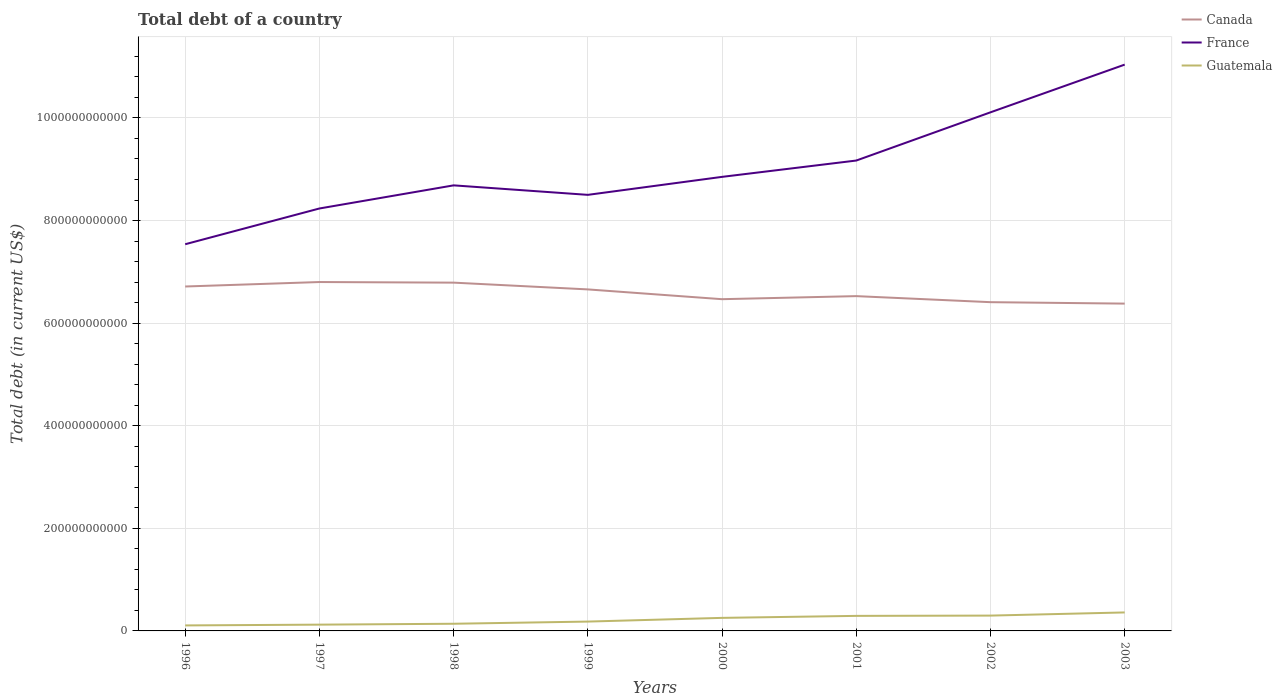How many different coloured lines are there?
Offer a very short reply. 3. Does the line corresponding to Canada intersect with the line corresponding to Guatemala?
Provide a short and direct response. No. Is the number of lines equal to the number of legend labels?
Provide a short and direct response. Yes. Across all years, what is the maximum debt in France?
Your answer should be compact. 7.54e+11. What is the total debt in France in the graph?
Offer a very short reply. -2.35e+11. What is the difference between the highest and the second highest debt in Guatemala?
Offer a terse response. 2.53e+1. What is the difference between the highest and the lowest debt in France?
Give a very brief answer. 3. How many lines are there?
Offer a very short reply. 3. What is the difference between two consecutive major ticks on the Y-axis?
Keep it short and to the point. 2.00e+11. Does the graph contain any zero values?
Make the answer very short. No. Does the graph contain grids?
Ensure brevity in your answer.  Yes. How many legend labels are there?
Your answer should be very brief. 3. What is the title of the graph?
Offer a terse response. Total debt of a country. Does "World" appear as one of the legend labels in the graph?
Your answer should be compact. No. What is the label or title of the Y-axis?
Your answer should be compact. Total debt (in current US$). What is the Total debt (in current US$) of Canada in 1996?
Your answer should be compact. 6.71e+11. What is the Total debt (in current US$) in France in 1996?
Make the answer very short. 7.54e+11. What is the Total debt (in current US$) in Guatemala in 1996?
Ensure brevity in your answer.  1.07e+1. What is the Total debt (in current US$) of Canada in 1997?
Ensure brevity in your answer.  6.80e+11. What is the Total debt (in current US$) of France in 1997?
Offer a very short reply. 8.24e+11. What is the Total debt (in current US$) of Guatemala in 1997?
Provide a succinct answer. 1.22e+1. What is the Total debt (in current US$) of Canada in 1998?
Offer a very short reply. 6.79e+11. What is the Total debt (in current US$) in France in 1998?
Ensure brevity in your answer.  8.69e+11. What is the Total debt (in current US$) of Guatemala in 1998?
Offer a very short reply. 1.40e+1. What is the Total debt (in current US$) in Canada in 1999?
Your answer should be very brief. 6.66e+11. What is the Total debt (in current US$) of France in 1999?
Keep it short and to the point. 8.50e+11. What is the Total debt (in current US$) in Guatemala in 1999?
Offer a very short reply. 1.82e+1. What is the Total debt (in current US$) of Canada in 2000?
Provide a succinct answer. 6.47e+11. What is the Total debt (in current US$) of France in 2000?
Provide a succinct answer. 8.85e+11. What is the Total debt (in current US$) of Guatemala in 2000?
Offer a terse response. 2.54e+1. What is the Total debt (in current US$) in Canada in 2001?
Keep it short and to the point. 6.53e+11. What is the Total debt (in current US$) of France in 2001?
Your answer should be very brief. 9.17e+11. What is the Total debt (in current US$) of Guatemala in 2001?
Provide a succinct answer. 2.93e+1. What is the Total debt (in current US$) in Canada in 2002?
Offer a terse response. 6.41e+11. What is the Total debt (in current US$) of France in 2002?
Ensure brevity in your answer.  1.01e+12. What is the Total debt (in current US$) in Guatemala in 2002?
Your answer should be compact. 2.99e+1. What is the Total debt (in current US$) in Canada in 2003?
Provide a short and direct response. 6.38e+11. What is the Total debt (in current US$) of France in 2003?
Your answer should be compact. 1.10e+12. What is the Total debt (in current US$) in Guatemala in 2003?
Your answer should be compact. 3.60e+1. Across all years, what is the maximum Total debt (in current US$) of Canada?
Offer a terse response. 6.80e+11. Across all years, what is the maximum Total debt (in current US$) in France?
Give a very brief answer. 1.10e+12. Across all years, what is the maximum Total debt (in current US$) in Guatemala?
Make the answer very short. 3.60e+1. Across all years, what is the minimum Total debt (in current US$) of Canada?
Your answer should be compact. 6.38e+11. Across all years, what is the minimum Total debt (in current US$) in France?
Provide a short and direct response. 7.54e+11. Across all years, what is the minimum Total debt (in current US$) of Guatemala?
Make the answer very short. 1.07e+1. What is the total Total debt (in current US$) in Canada in the graph?
Provide a succinct answer. 5.27e+12. What is the total Total debt (in current US$) in France in the graph?
Your answer should be very brief. 7.21e+12. What is the total Total debt (in current US$) of Guatemala in the graph?
Provide a short and direct response. 1.76e+11. What is the difference between the Total debt (in current US$) of Canada in 1996 and that in 1997?
Your response must be concise. -8.71e+09. What is the difference between the Total debt (in current US$) of France in 1996 and that in 1997?
Your answer should be compact. -6.97e+1. What is the difference between the Total debt (in current US$) in Guatemala in 1996 and that in 1997?
Your answer should be very brief. -1.50e+09. What is the difference between the Total debt (in current US$) in Canada in 1996 and that in 1998?
Your answer should be very brief. -7.54e+09. What is the difference between the Total debt (in current US$) of France in 1996 and that in 1998?
Your answer should be very brief. -1.15e+11. What is the difference between the Total debt (in current US$) of Guatemala in 1996 and that in 1998?
Ensure brevity in your answer.  -3.26e+09. What is the difference between the Total debt (in current US$) of Canada in 1996 and that in 1999?
Offer a terse response. 5.66e+09. What is the difference between the Total debt (in current US$) in France in 1996 and that in 1999?
Offer a very short reply. -9.63e+1. What is the difference between the Total debt (in current US$) in Guatemala in 1996 and that in 1999?
Provide a short and direct response. -7.49e+09. What is the difference between the Total debt (in current US$) of Canada in 1996 and that in 2000?
Your answer should be very brief. 2.47e+1. What is the difference between the Total debt (in current US$) of France in 1996 and that in 2000?
Ensure brevity in your answer.  -1.31e+11. What is the difference between the Total debt (in current US$) in Guatemala in 1996 and that in 2000?
Ensure brevity in your answer.  -1.47e+1. What is the difference between the Total debt (in current US$) of Canada in 1996 and that in 2001?
Make the answer very short. 1.88e+1. What is the difference between the Total debt (in current US$) of France in 1996 and that in 2001?
Make the answer very short. -1.63e+11. What is the difference between the Total debt (in current US$) of Guatemala in 1996 and that in 2001?
Your answer should be compact. -1.86e+1. What is the difference between the Total debt (in current US$) of Canada in 1996 and that in 2002?
Ensure brevity in your answer.  3.06e+1. What is the difference between the Total debt (in current US$) of France in 1996 and that in 2002?
Provide a succinct answer. -2.57e+11. What is the difference between the Total debt (in current US$) of Guatemala in 1996 and that in 2002?
Your response must be concise. -1.92e+1. What is the difference between the Total debt (in current US$) of Canada in 1996 and that in 2003?
Offer a very short reply. 3.33e+1. What is the difference between the Total debt (in current US$) of France in 1996 and that in 2003?
Your answer should be very brief. -3.50e+11. What is the difference between the Total debt (in current US$) of Guatemala in 1996 and that in 2003?
Give a very brief answer. -2.53e+1. What is the difference between the Total debt (in current US$) of Canada in 1997 and that in 1998?
Your response must be concise. 1.16e+09. What is the difference between the Total debt (in current US$) in France in 1997 and that in 1998?
Offer a terse response. -4.51e+1. What is the difference between the Total debt (in current US$) in Guatemala in 1997 and that in 1998?
Ensure brevity in your answer.  -1.75e+09. What is the difference between the Total debt (in current US$) of Canada in 1997 and that in 1999?
Ensure brevity in your answer.  1.44e+1. What is the difference between the Total debt (in current US$) of France in 1997 and that in 1999?
Offer a terse response. -2.66e+1. What is the difference between the Total debt (in current US$) of Guatemala in 1997 and that in 1999?
Give a very brief answer. -5.98e+09. What is the difference between the Total debt (in current US$) of Canada in 1997 and that in 2000?
Offer a terse response. 3.34e+1. What is the difference between the Total debt (in current US$) of France in 1997 and that in 2000?
Make the answer very short. -6.16e+1. What is the difference between the Total debt (in current US$) of Guatemala in 1997 and that in 2000?
Keep it short and to the point. -1.32e+1. What is the difference between the Total debt (in current US$) in Canada in 1997 and that in 2001?
Provide a succinct answer. 2.75e+1. What is the difference between the Total debt (in current US$) of France in 1997 and that in 2001?
Provide a succinct answer. -9.35e+1. What is the difference between the Total debt (in current US$) in Guatemala in 1997 and that in 2001?
Offer a terse response. -1.71e+1. What is the difference between the Total debt (in current US$) of Canada in 1997 and that in 2002?
Your response must be concise. 3.93e+1. What is the difference between the Total debt (in current US$) of France in 1997 and that in 2002?
Offer a very short reply. -1.87e+11. What is the difference between the Total debt (in current US$) in Guatemala in 1997 and that in 2002?
Ensure brevity in your answer.  -1.77e+1. What is the difference between the Total debt (in current US$) of Canada in 1997 and that in 2003?
Your answer should be very brief. 4.20e+1. What is the difference between the Total debt (in current US$) of France in 1997 and that in 2003?
Provide a succinct answer. -2.80e+11. What is the difference between the Total debt (in current US$) of Guatemala in 1997 and that in 2003?
Provide a succinct answer. -2.38e+1. What is the difference between the Total debt (in current US$) in Canada in 1998 and that in 1999?
Offer a very short reply. 1.32e+1. What is the difference between the Total debt (in current US$) in France in 1998 and that in 1999?
Keep it short and to the point. 1.85e+1. What is the difference between the Total debt (in current US$) in Guatemala in 1998 and that in 1999?
Provide a short and direct response. -4.23e+09. What is the difference between the Total debt (in current US$) in Canada in 1998 and that in 2000?
Provide a short and direct response. 3.23e+1. What is the difference between the Total debt (in current US$) of France in 1998 and that in 2000?
Offer a very short reply. -1.66e+1. What is the difference between the Total debt (in current US$) of Guatemala in 1998 and that in 2000?
Your answer should be very brief. -1.14e+1. What is the difference between the Total debt (in current US$) in Canada in 1998 and that in 2001?
Ensure brevity in your answer.  2.63e+1. What is the difference between the Total debt (in current US$) in France in 1998 and that in 2001?
Ensure brevity in your answer.  -4.84e+1. What is the difference between the Total debt (in current US$) of Guatemala in 1998 and that in 2001?
Provide a succinct answer. -1.53e+1. What is the difference between the Total debt (in current US$) of Canada in 1998 and that in 2002?
Offer a terse response. 3.81e+1. What is the difference between the Total debt (in current US$) in France in 1998 and that in 2002?
Keep it short and to the point. -1.42e+11. What is the difference between the Total debt (in current US$) of Guatemala in 1998 and that in 2002?
Keep it short and to the point. -1.59e+1. What is the difference between the Total debt (in current US$) of Canada in 1998 and that in 2003?
Ensure brevity in your answer.  4.09e+1. What is the difference between the Total debt (in current US$) in France in 1998 and that in 2003?
Offer a terse response. -2.35e+11. What is the difference between the Total debt (in current US$) in Guatemala in 1998 and that in 2003?
Your response must be concise. -2.21e+1. What is the difference between the Total debt (in current US$) of Canada in 1999 and that in 2000?
Provide a succinct answer. 1.91e+1. What is the difference between the Total debt (in current US$) of France in 1999 and that in 2000?
Your response must be concise. -3.51e+1. What is the difference between the Total debt (in current US$) of Guatemala in 1999 and that in 2000?
Ensure brevity in your answer.  -7.21e+09. What is the difference between the Total debt (in current US$) in Canada in 1999 and that in 2001?
Your response must be concise. 1.31e+1. What is the difference between the Total debt (in current US$) in France in 1999 and that in 2001?
Your response must be concise. -6.69e+1. What is the difference between the Total debt (in current US$) in Guatemala in 1999 and that in 2001?
Ensure brevity in your answer.  -1.11e+1. What is the difference between the Total debt (in current US$) of Canada in 1999 and that in 2002?
Your answer should be very brief. 2.49e+1. What is the difference between the Total debt (in current US$) in France in 1999 and that in 2002?
Make the answer very short. -1.61e+11. What is the difference between the Total debt (in current US$) of Guatemala in 1999 and that in 2002?
Offer a terse response. -1.17e+1. What is the difference between the Total debt (in current US$) of Canada in 1999 and that in 2003?
Your answer should be compact. 2.77e+1. What is the difference between the Total debt (in current US$) of France in 1999 and that in 2003?
Ensure brevity in your answer.  -2.54e+11. What is the difference between the Total debt (in current US$) of Guatemala in 1999 and that in 2003?
Your answer should be very brief. -1.78e+1. What is the difference between the Total debt (in current US$) in Canada in 2000 and that in 2001?
Your answer should be compact. -5.98e+09. What is the difference between the Total debt (in current US$) in France in 2000 and that in 2001?
Offer a very short reply. -3.18e+1. What is the difference between the Total debt (in current US$) of Guatemala in 2000 and that in 2001?
Offer a terse response. -3.88e+09. What is the difference between the Total debt (in current US$) in Canada in 2000 and that in 2002?
Make the answer very short. 5.82e+09. What is the difference between the Total debt (in current US$) in France in 2000 and that in 2002?
Provide a short and direct response. -1.26e+11. What is the difference between the Total debt (in current US$) in Guatemala in 2000 and that in 2002?
Offer a very short reply. -4.46e+09. What is the difference between the Total debt (in current US$) of Canada in 2000 and that in 2003?
Ensure brevity in your answer.  8.59e+09. What is the difference between the Total debt (in current US$) of France in 2000 and that in 2003?
Keep it short and to the point. -2.19e+11. What is the difference between the Total debt (in current US$) of Guatemala in 2000 and that in 2003?
Give a very brief answer. -1.06e+1. What is the difference between the Total debt (in current US$) in Canada in 2001 and that in 2002?
Provide a short and direct response. 1.18e+1. What is the difference between the Total debt (in current US$) in France in 2001 and that in 2002?
Your response must be concise. -9.40e+1. What is the difference between the Total debt (in current US$) of Guatemala in 2001 and that in 2002?
Make the answer very short. -5.74e+08. What is the difference between the Total debt (in current US$) in Canada in 2001 and that in 2003?
Offer a very short reply. 1.46e+1. What is the difference between the Total debt (in current US$) of France in 2001 and that in 2003?
Give a very brief answer. -1.87e+11. What is the difference between the Total debt (in current US$) of Guatemala in 2001 and that in 2003?
Keep it short and to the point. -6.73e+09. What is the difference between the Total debt (in current US$) in Canada in 2002 and that in 2003?
Your answer should be compact. 2.78e+09. What is the difference between the Total debt (in current US$) in France in 2002 and that in 2003?
Your answer should be compact. -9.30e+1. What is the difference between the Total debt (in current US$) in Guatemala in 2002 and that in 2003?
Ensure brevity in your answer.  -6.16e+09. What is the difference between the Total debt (in current US$) in Canada in 1996 and the Total debt (in current US$) in France in 1997?
Give a very brief answer. -1.52e+11. What is the difference between the Total debt (in current US$) of Canada in 1996 and the Total debt (in current US$) of Guatemala in 1997?
Offer a terse response. 6.59e+11. What is the difference between the Total debt (in current US$) in France in 1996 and the Total debt (in current US$) in Guatemala in 1997?
Keep it short and to the point. 7.42e+11. What is the difference between the Total debt (in current US$) in Canada in 1996 and the Total debt (in current US$) in France in 1998?
Give a very brief answer. -1.97e+11. What is the difference between the Total debt (in current US$) in Canada in 1996 and the Total debt (in current US$) in Guatemala in 1998?
Offer a terse response. 6.57e+11. What is the difference between the Total debt (in current US$) of France in 1996 and the Total debt (in current US$) of Guatemala in 1998?
Provide a succinct answer. 7.40e+11. What is the difference between the Total debt (in current US$) in Canada in 1996 and the Total debt (in current US$) in France in 1999?
Your response must be concise. -1.79e+11. What is the difference between the Total debt (in current US$) in Canada in 1996 and the Total debt (in current US$) in Guatemala in 1999?
Offer a very short reply. 6.53e+11. What is the difference between the Total debt (in current US$) of France in 1996 and the Total debt (in current US$) of Guatemala in 1999?
Provide a short and direct response. 7.36e+11. What is the difference between the Total debt (in current US$) of Canada in 1996 and the Total debt (in current US$) of France in 2000?
Offer a very short reply. -2.14e+11. What is the difference between the Total debt (in current US$) of Canada in 1996 and the Total debt (in current US$) of Guatemala in 2000?
Your response must be concise. 6.46e+11. What is the difference between the Total debt (in current US$) in France in 1996 and the Total debt (in current US$) in Guatemala in 2000?
Make the answer very short. 7.28e+11. What is the difference between the Total debt (in current US$) in Canada in 1996 and the Total debt (in current US$) in France in 2001?
Give a very brief answer. -2.46e+11. What is the difference between the Total debt (in current US$) of Canada in 1996 and the Total debt (in current US$) of Guatemala in 2001?
Offer a terse response. 6.42e+11. What is the difference between the Total debt (in current US$) in France in 1996 and the Total debt (in current US$) in Guatemala in 2001?
Offer a very short reply. 7.25e+11. What is the difference between the Total debt (in current US$) of Canada in 1996 and the Total debt (in current US$) of France in 2002?
Provide a succinct answer. -3.40e+11. What is the difference between the Total debt (in current US$) in Canada in 1996 and the Total debt (in current US$) in Guatemala in 2002?
Keep it short and to the point. 6.42e+11. What is the difference between the Total debt (in current US$) of France in 1996 and the Total debt (in current US$) of Guatemala in 2002?
Your response must be concise. 7.24e+11. What is the difference between the Total debt (in current US$) of Canada in 1996 and the Total debt (in current US$) of France in 2003?
Provide a succinct answer. -4.33e+11. What is the difference between the Total debt (in current US$) in Canada in 1996 and the Total debt (in current US$) in Guatemala in 2003?
Offer a very short reply. 6.35e+11. What is the difference between the Total debt (in current US$) of France in 1996 and the Total debt (in current US$) of Guatemala in 2003?
Give a very brief answer. 7.18e+11. What is the difference between the Total debt (in current US$) in Canada in 1997 and the Total debt (in current US$) in France in 1998?
Your answer should be very brief. -1.88e+11. What is the difference between the Total debt (in current US$) of Canada in 1997 and the Total debt (in current US$) of Guatemala in 1998?
Offer a very short reply. 6.66e+11. What is the difference between the Total debt (in current US$) of France in 1997 and the Total debt (in current US$) of Guatemala in 1998?
Offer a very short reply. 8.10e+11. What is the difference between the Total debt (in current US$) of Canada in 1997 and the Total debt (in current US$) of France in 1999?
Ensure brevity in your answer.  -1.70e+11. What is the difference between the Total debt (in current US$) of Canada in 1997 and the Total debt (in current US$) of Guatemala in 1999?
Offer a terse response. 6.62e+11. What is the difference between the Total debt (in current US$) in France in 1997 and the Total debt (in current US$) in Guatemala in 1999?
Provide a succinct answer. 8.05e+11. What is the difference between the Total debt (in current US$) of Canada in 1997 and the Total debt (in current US$) of France in 2000?
Offer a terse response. -2.05e+11. What is the difference between the Total debt (in current US$) of Canada in 1997 and the Total debt (in current US$) of Guatemala in 2000?
Offer a terse response. 6.55e+11. What is the difference between the Total debt (in current US$) of France in 1997 and the Total debt (in current US$) of Guatemala in 2000?
Your answer should be very brief. 7.98e+11. What is the difference between the Total debt (in current US$) in Canada in 1997 and the Total debt (in current US$) in France in 2001?
Give a very brief answer. -2.37e+11. What is the difference between the Total debt (in current US$) in Canada in 1997 and the Total debt (in current US$) in Guatemala in 2001?
Provide a short and direct response. 6.51e+11. What is the difference between the Total debt (in current US$) in France in 1997 and the Total debt (in current US$) in Guatemala in 2001?
Make the answer very short. 7.94e+11. What is the difference between the Total debt (in current US$) of Canada in 1997 and the Total debt (in current US$) of France in 2002?
Your answer should be very brief. -3.31e+11. What is the difference between the Total debt (in current US$) of Canada in 1997 and the Total debt (in current US$) of Guatemala in 2002?
Give a very brief answer. 6.50e+11. What is the difference between the Total debt (in current US$) in France in 1997 and the Total debt (in current US$) in Guatemala in 2002?
Ensure brevity in your answer.  7.94e+11. What is the difference between the Total debt (in current US$) of Canada in 1997 and the Total debt (in current US$) of France in 2003?
Your response must be concise. -4.24e+11. What is the difference between the Total debt (in current US$) of Canada in 1997 and the Total debt (in current US$) of Guatemala in 2003?
Ensure brevity in your answer.  6.44e+11. What is the difference between the Total debt (in current US$) in France in 1997 and the Total debt (in current US$) in Guatemala in 2003?
Your response must be concise. 7.87e+11. What is the difference between the Total debt (in current US$) in Canada in 1998 and the Total debt (in current US$) in France in 1999?
Your answer should be compact. -1.71e+11. What is the difference between the Total debt (in current US$) of Canada in 1998 and the Total debt (in current US$) of Guatemala in 1999?
Your answer should be compact. 6.61e+11. What is the difference between the Total debt (in current US$) in France in 1998 and the Total debt (in current US$) in Guatemala in 1999?
Provide a succinct answer. 8.50e+11. What is the difference between the Total debt (in current US$) of Canada in 1998 and the Total debt (in current US$) of France in 2000?
Your answer should be very brief. -2.06e+11. What is the difference between the Total debt (in current US$) in Canada in 1998 and the Total debt (in current US$) in Guatemala in 2000?
Your answer should be compact. 6.54e+11. What is the difference between the Total debt (in current US$) of France in 1998 and the Total debt (in current US$) of Guatemala in 2000?
Offer a terse response. 8.43e+11. What is the difference between the Total debt (in current US$) in Canada in 1998 and the Total debt (in current US$) in France in 2001?
Keep it short and to the point. -2.38e+11. What is the difference between the Total debt (in current US$) of Canada in 1998 and the Total debt (in current US$) of Guatemala in 2001?
Your response must be concise. 6.50e+11. What is the difference between the Total debt (in current US$) of France in 1998 and the Total debt (in current US$) of Guatemala in 2001?
Ensure brevity in your answer.  8.39e+11. What is the difference between the Total debt (in current US$) in Canada in 1998 and the Total debt (in current US$) in France in 2002?
Make the answer very short. -3.32e+11. What is the difference between the Total debt (in current US$) in Canada in 1998 and the Total debt (in current US$) in Guatemala in 2002?
Keep it short and to the point. 6.49e+11. What is the difference between the Total debt (in current US$) in France in 1998 and the Total debt (in current US$) in Guatemala in 2002?
Offer a very short reply. 8.39e+11. What is the difference between the Total debt (in current US$) of Canada in 1998 and the Total debt (in current US$) of France in 2003?
Keep it short and to the point. -4.25e+11. What is the difference between the Total debt (in current US$) of Canada in 1998 and the Total debt (in current US$) of Guatemala in 2003?
Ensure brevity in your answer.  6.43e+11. What is the difference between the Total debt (in current US$) in France in 1998 and the Total debt (in current US$) in Guatemala in 2003?
Provide a succinct answer. 8.33e+11. What is the difference between the Total debt (in current US$) of Canada in 1999 and the Total debt (in current US$) of France in 2000?
Provide a short and direct response. -2.19e+11. What is the difference between the Total debt (in current US$) of Canada in 1999 and the Total debt (in current US$) of Guatemala in 2000?
Ensure brevity in your answer.  6.40e+11. What is the difference between the Total debt (in current US$) in France in 1999 and the Total debt (in current US$) in Guatemala in 2000?
Provide a short and direct response. 8.25e+11. What is the difference between the Total debt (in current US$) of Canada in 1999 and the Total debt (in current US$) of France in 2001?
Your answer should be compact. -2.51e+11. What is the difference between the Total debt (in current US$) in Canada in 1999 and the Total debt (in current US$) in Guatemala in 2001?
Your response must be concise. 6.36e+11. What is the difference between the Total debt (in current US$) of France in 1999 and the Total debt (in current US$) of Guatemala in 2001?
Make the answer very short. 8.21e+11. What is the difference between the Total debt (in current US$) in Canada in 1999 and the Total debt (in current US$) in France in 2002?
Provide a succinct answer. -3.45e+11. What is the difference between the Total debt (in current US$) of Canada in 1999 and the Total debt (in current US$) of Guatemala in 2002?
Give a very brief answer. 6.36e+11. What is the difference between the Total debt (in current US$) in France in 1999 and the Total debt (in current US$) in Guatemala in 2002?
Your response must be concise. 8.20e+11. What is the difference between the Total debt (in current US$) in Canada in 1999 and the Total debt (in current US$) in France in 2003?
Offer a very short reply. -4.38e+11. What is the difference between the Total debt (in current US$) in Canada in 1999 and the Total debt (in current US$) in Guatemala in 2003?
Ensure brevity in your answer.  6.30e+11. What is the difference between the Total debt (in current US$) of France in 1999 and the Total debt (in current US$) of Guatemala in 2003?
Your answer should be compact. 8.14e+11. What is the difference between the Total debt (in current US$) in Canada in 2000 and the Total debt (in current US$) in France in 2001?
Give a very brief answer. -2.70e+11. What is the difference between the Total debt (in current US$) of Canada in 2000 and the Total debt (in current US$) of Guatemala in 2001?
Provide a succinct answer. 6.17e+11. What is the difference between the Total debt (in current US$) in France in 2000 and the Total debt (in current US$) in Guatemala in 2001?
Offer a terse response. 8.56e+11. What is the difference between the Total debt (in current US$) in Canada in 2000 and the Total debt (in current US$) in France in 2002?
Make the answer very short. -3.64e+11. What is the difference between the Total debt (in current US$) of Canada in 2000 and the Total debt (in current US$) of Guatemala in 2002?
Provide a short and direct response. 6.17e+11. What is the difference between the Total debt (in current US$) of France in 2000 and the Total debt (in current US$) of Guatemala in 2002?
Ensure brevity in your answer.  8.55e+11. What is the difference between the Total debt (in current US$) in Canada in 2000 and the Total debt (in current US$) in France in 2003?
Provide a succinct answer. -4.57e+11. What is the difference between the Total debt (in current US$) of Canada in 2000 and the Total debt (in current US$) of Guatemala in 2003?
Make the answer very short. 6.11e+11. What is the difference between the Total debt (in current US$) of France in 2000 and the Total debt (in current US$) of Guatemala in 2003?
Make the answer very short. 8.49e+11. What is the difference between the Total debt (in current US$) of Canada in 2001 and the Total debt (in current US$) of France in 2002?
Offer a terse response. -3.58e+11. What is the difference between the Total debt (in current US$) in Canada in 2001 and the Total debt (in current US$) in Guatemala in 2002?
Make the answer very short. 6.23e+11. What is the difference between the Total debt (in current US$) in France in 2001 and the Total debt (in current US$) in Guatemala in 2002?
Offer a terse response. 8.87e+11. What is the difference between the Total debt (in current US$) in Canada in 2001 and the Total debt (in current US$) in France in 2003?
Offer a very short reply. -4.51e+11. What is the difference between the Total debt (in current US$) in Canada in 2001 and the Total debt (in current US$) in Guatemala in 2003?
Your answer should be compact. 6.17e+11. What is the difference between the Total debt (in current US$) of France in 2001 and the Total debt (in current US$) of Guatemala in 2003?
Your answer should be very brief. 8.81e+11. What is the difference between the Total debt (in current US$) in Canada in 2002 and the Total debt (in current US$) in France in 2003?
Provide a succinct answer. -4.63e+11. What is the difference between the Total debt (in current US$) of Canada in 2002 and the Total debt (in current US$) of Guatemala in 2003?
Your answer should be compact. 6.05e+11. What is the difference between the Total debt (in current US$) of France in 2002 and the Total debt (in current US$) of Guatemala in 2003?
Your answer should be compact. 9.75e+11. What is the average Total debt (in current US$) in Canada per year?
Provide a short and direct response. 6.59e+11. What is the average Total debt (in current US$) of France per year?
Offer a terse response. 9.02e+11. What is the average Total debt (in current US$) in Guatemala per year?
Offer a terse response. 2.20e+1. In the year 1996, what is the difference between the Total debt (in current US$) of Canada and Total debt (in current US$) of France?
Ensure brevity in your answer.  -8.24e+1. In the year 1996, what is the difference between the Total debt (in current US$) of Canada and Total debt (in current US$) of Guatemala?
Offer a terse response. 6.61e+11. In the year 1996, what is the difference between the Total debt (in current US$) of France and Total debt (in current US$) of Guatemala?
Your answer should be very brief. 7.43e+11. In the year 1997, what is the difference between the Total debt (in current US$) in Canada and Total debt (in current US$) in France?
Offer a terse response. -1.43e+11. In the year 1997, what is the difference between the Total debt (in current US$) of Canada and Total debt (in current US$) of Guatemala?
Provide a short and direct response. 6.68e+11. In the year 1997, what is the difference between the Total debt (in current US$) of France and Total debt (in current US$) of Guatemala?
Your answer should be very brief. 8.11e+11. In the year 1998, what is the difference between the Total debt (in current US$) of Canada and Total debt (in current US$) of France?
Your answer should be compact. -1.90e+11. In the year 1998, what is the difference between the Total debt (in current US$) of Canada and Total debt (in current US$) of Guatemala?
Your response must be concise. 6.65e+11. In the year 1998, what is the difference between the Total debt (in current US$) in France and Total debt (in current US$) in Guatemala?
Your answer should be compact. 8.55e+11. In the year 1999, what is the difference between the Total debt (in current US$) of Canada and Total debt (in current US$) of France?
Your answer should be very brief. -1.84e+11. In the year 1999, what is the difference between the Total debt (in current US$) in Canada and Total debt (in current US$) in Guatemala?
Give a very brief answer. 6.48e+11. In the year 1999, what is the difference between the Total debt (in current US$) of France and Total debt (in current US$) of Guatemala?
Your response must be concise. 8.32e+11. In the year 2000, what is the difference between the Total debt (in current US$) in Canada and Total debt (in current US$) in France?
Your answer should be compact. -2.38e+11. In the year 2000, what is the difference between the Total debt (in current US$) of Canada and Total debt (in current US$) of Guatemala?
Make the answer very short. 6.21e+11. In the year 2000, what is the difference between the Total debt (in current US$) in France and Total debt (in current US$) in Guatemala?
Your answer should be very brief. 8.60e+11. In the year 2001, what is the difference between the Total debt (in current US$) in Canada and Total debt (in current US$) in France?
Give a very brief answer. -2.64e+11. In the year 2001, what is the difference between the Total debt (in current US$) of Canada and Total debt (in current US$) of Guatemala?
Keep it short and to the point. 6.23e+11. In the year 2001, what is the difference between the Total debt (in current US$) of France and Total debt (in current US$) of Guatemala?
Your answer should be very brief. 8.88e+11. In the year 2002, what is the difference between the Total debt (in current US$) of Canada and Total debt (in current US$) of France?
Provide a succinct answer. -3.70e+11. In the year 2002, what is the difference between the Total debt (in current US$) in Canada and Total debt (in current US$) in Guatemala?
Make the answer very short. 6.11e+11. In the year 2002, what is the difference between the Total debt (in current US$) of France and Total debt (in current US$) of Guatemala?
Offer a terse response. 9.81e+11. In the year 2003, what is the difference between the Total debt (in current US$) in Canada and Total debt (in current US$) in France?
Give a very brief answer. -4.66e+11. In the year 2003, what is the difference between the Total debt (in current US$) of Canada and Total debt (in current US$) of Guatemala?
Ensure brevity in your answer.  6.02e+11. In the year 2003, what is the difference between the Total debt (in current US$) in France and Total debt (in current US$) in Guatemala?
Keep it short and to the point. 1.07e+12. What is the ratio of the Total debt (in current US$) of Canada in 1996 to that in 1997?
Offer a terse response. 0.99. What is the ratio of the Total debt (in current US$) in France in 1996 to that in 1997?
Provide a short and direct response. 0.92. What is the ratio of the Total debt (in current US$) in Guatemala in 1996 to that in 1997?
Offer a terse response. 0.88. What is the ratio of the Total debt (in current US$) in Canada in 1996 to that in 1998?
Ensure brevity in your answer.  0.99. What is the ratio of the Total debt (in current US$) in France in 1996 to that in 1998?
Provide a short and direct response. 0.87. What is the ratio of the Total debt (in current US$) of Guatemala in 1996 to that in 1998?
Your answer should be very brief. 0.77. What is the ratio of the Total debt (in current US$) in Canada in 1996 to that in 1999?
Ensure brevity in your answer.  1.01. What is the ratio of the Total debt (in current US$) of France in 1996 to that in 1999?
Your answer should be compact. 0.89. What is the ratio of the Total debt (in current US$) in Guatemala in 1996 to that in 1999?
Provide a short and direct response. 0.59. What is the ratio of the Total debt (in current US$) of Canada in 1996 to that in 2000?
Your answer should be very brief. 1.04. What is the ratio of the Total debt (in current US$) of France in 1996 to that in 2000?
Make the answer very short. 0.85. What is the ratio of the Total debt (in current US$) in Guatemala in 1996 to that in 2000?
Your answer should be very brief. 0.42. What is the ratio of the Total debt (in current US$) in Canada in 1996 to that in 2001?
Your response must be concise. 1.03. What is the ratio of the Total debt (in current US$) of France in 1996 to that in 2001?
Ensure brevity in your answer.  0.82. What is the ratio of the Total debt (in current US$) in Guatemala in 1996 to that in 2001?
Your answer should be very brief. 0.37. What is the ratio of the Total debt (in current US$) in Canada in 1996 to that in 2002?
Your answer should be very brief. 1.05. What is the ratio of the Total debt (in current US$) of France in 1996 to that in 2002?
Offer a very short reply. 0.75. What is the ratio of the Total debt (in current US$) of Guatemala in 1996 to that in 2002?
Provide a succinct answer. 0.36. What is the ratio of the Total debt (in current US$) of Canada in 1996 to that in 2003?
Ensure brevity in your answer.  1.05. What is the ratio of the Total debt (in current US$) of France in 1996 to that in 2003?
Ensure brevity in your answer.  0.68. What is the ratio of the Total debt (in current US$) in Guatemala in 1996 to that in 2003?
Your response must be concise. 0.3. What is the ratio of the Total debt (in current US$) of France in 1997 to that in 1998?
Provide a short and direct response. 0.95. What is the ratio of the Total debt (in current US$) in Guatemala in 1997 to that in 1998?
Your answer should be compact. 0.87. What is the ratio of the Total debt (in current US$) in Canada in 1997 to that in 1999?
Provide a succinct answer. 1.02. What is the ratio of the Total debt (in current US$) in France in 1997 to that in 1999?
Keep it short and to the point. 0.97. What is the ratio of the Total debt (in current US$) in Guatemala in 1997 to that in 1999?
Ensure brevity in your answer.  0.67. What is the ratio of the Total debt (in current US$) in Canada in 1997 to that in 2000?
Offer a very short reply. 1.05. What is the ratio of the Total debt (in current US$) in France in 1997 to that in 2000?
Your answer should be very brief. 0.93. What is the ratio of the Total debt (in current US$) in Guatemala in 1997 to that in 2000?
Ensure brevity in your answer.  0.48. What is the ratio of the Total debt (in current US$) of Canada in 1997 to that in 2001?
Keep it short and to the point. 1.04. What is the ratio of the Total debt (in current US$) of France in 1997 to that in 2001?
Provide a short and direct response. 0.9. What is the ratio of the Total debt (in current US$) of Guatemala in 1997 to that in 2001?
Your response must be concise. 0.42. What is the ratio of the Total debt (in current US$) of Canada in 1997 to that in 2002?
Your response must be concise. 1.06. What is the ratio of the Total debt (in current US$) of France in 1997 to that in 2002?
Provide a succinct answer. 0.81. What is the ratio of the Total debt (in current US$) in Guatemala in 1997 to that in 2002?
Keep it short and to the point. 0.41. What is the ratio of the Total debt (in current US$) of Canada in 1997 to that in 2003?
Ensure brevity in your answer.  1.07. What is the ratio of the Total debt (in current US$) in France in 1997 to that in 2003?
Ensure brevity in your answer.  0.75. What is the ratio of the Total debt (in current US$) in Guatemala in 1997 to that in 2003?
Provide a short and direct response. 0.34. What is the ratio of the Total debt (in current US$) in Canada in 1998 to that in 1999?
Ensure brevity in your answer.  1.02. What is the ratio of the Total debt (in current US$) in France in 1998 to that in 1999?
Keep it short and to the point. 1.02. What is the ratio of the Total debt (in current US$) of Guatemala in 1998 to that in 1999?
Keep it short and to the point. 0.77. What is the ratio of the Total debt (in current US$) of Canada in 1998 to that in 2000?
Make the answer very short. 1.05. What is the ratio of the Total debt (in current US$) of France in 1998 to that in 2000?
Offer a terse response. 0.98. What is the ratio of the Total debt (in current US$) in Guatemala in 1998 to that in 2000?
Provide a short and direct response. 0.55. What is the ratio of the Total debt (in current US$) of Canada in 1998 to that in 2001?
Offer a very short reply. 1.04. What is the ratio of the Total debt (in current US$) of France in 1998 to that in 2001?
Your response must be concise. 0.95. What is the ratio of the Total debt (in current US$) of Guatemala in 1998 to that in 2001?
Your answer should be compact. 0.48. What is the ratio of the Total debt (in current US$) in Canada in 1998 to that in 2002?
Give a very brief answer. 1.06. What is the ratio of the Total debt (in current US$) of France in 1998 to that in 2002?
Keep it short and to the point. 0.86. What is the ratio of the Total debt (in current US$) in Guatemala in 1998 to that in 2002?
Keep it short and to the point. 0.47. What is the ratio of the Total debt (in current US$) in Canada in 1998 to that in 2003?
Your answer should be very brief. 1.06. What is the ratio of the Total debt (in current US$) in France in 1998 to that in 2003?
Your answer should be very brief. 0.79. What is the ratio of the Total debt (in current US$) of Guatemala in 1998 to that in 2003?
Keep it short and to the point. 0.39. What is the ratio of the Total debt (in current US$) of Canada in 1999 to that in 2000?
Ensure brevity in your answer.  1.03. What is the ratio of the Total debt (in current US$) in France in 1999 to that in 2000?
Your answer should be compact. 0.96. What is the ratio of the Total debt (in current US$) of Guatemala in 1999 to that in 2000?
Offer a terse response. 0.72. What is the ratio of the Total debt (in current US$) in Canada in 1999 to that in 2001?
Keep it short and to the point. 1.02. What is the ratio of the Total debt (in current US$) in France in 1999 to that in 2001?
Give a very brief answer. 0.93. What is the ratio of the Total debt (in current US$) in Guatemala in 1999 to that in 2001?
Make the answer very short. 0.62. What is the ratio of the Total debt (in current US$) of Canada in 1999 to that in 2002?
Offer a very short reply. 1.04. What is the ratio of the Total debt (in current US$) in France in 1999 to that in 2002?
Your response must be concise. 0.84. What is the ratio of the Total debt (in current US$) in Guatemala in 1999 to that in 2002?
Keep it short and to the point. 0.61. What is the ratio of the Total debt (in current US$) in Canada in 1999 to that in 2003?
Your response must be concise. 1.04. What is the ratio of the Total debt (in current US$) in France in 1999 to that in 2003?
Your answer should be compact. 0.77. What is the ratio of the Total debt (in current US$) in Guatemala in 1999 to that in 2003?
Provide a short and direct response. 0.51. What is the ratio of the Total debt (in current US$) of Canada in 2000 to that in 2001?
Offer a very short reply. 0.99. What is the ratio of the Total debt (in current US$) of France in 2000 to that in 2001?
Provide a short and direct response. 0.97. What is the ratio of the Total debt (in current US$) of Guatemala in 2000 to that in 2001?
Offer a terse response. 0.87. What is the ratio of the Total debt (in current US$) in Canada in 2000 to that in 2002?
Offer a very short reply. 1.01. What is the ratio of the Total debt (in current US$) of France in 2000 to that in 2002?
Keep it short and to the point. 0.88. What is the ratio of the Total debt (in current US$) in Guatemala in 2000 to that in 2002?
Your response must be concise. 0.85. What is the ratio of the Total debt (in current US$) of Canada in 2000 to that in 2003?
Provide a short and direct response. 1.01. What is the ratio of the Total debt (in current US$) in France in 2000 to that in 2003?
Your answer should be very brief. 0.8. What is the ratio of the Total debt (in current US$) in Guatemala in 2000 to that in 2003?
Your response must be concise. 0.71. What is the ratio of the Total debt (in current US$) in Canada in 2001 to that in 2002?
Give a very brief answer. 1.02. What is the ratio of the Total debt (in current US$) of France in 2001 to that in 2002?
Offer a very short reply. 0.91. What is the ratio of the Total debt (in current US$) in Guatemala in 2001 to that in 2002?
Your answer should be compact. 0.98. What is the ratio of the Total debt (in current US$) in Canada in 2001 to that in 2003?
Your response must be concise. 1.02. What is the ratio of the Total debt (in current US$) in France in 2001 to that in 2003?
Give a very brief answer. 0.83. What is the ratio of the Total debt (in current US$) of Guatemala in 2001 to that in 2003?
Your response must be concise. 0.81. What is the ratio of the Total debt (in current US$) of Canada in 2002 to that in 2003?
Provide a succinct answer. 1. What is the ratio of the Total debt (in current US$) in France in 2002 to that in 2003?
Ensure brevity in your answer.  0.92. What is the ratio of the Total debt (in current US$) of Guatemala in 2002 to that in 2003?
Offer a terse response. 0.83. What is the difference between the highest and the second highest Total debt (in current US$) in Canada?
Offer a very short reply. 1.16e+09. What is the difference between the highest and the second highest Total debt (in current US$) of France?
Your answer should be very brief. 9.30e+1. What is the difference between the highest and the second highest Total debt (in current US$) of Guatemala?
Provide a short and direct response. 6.16e+09. What is the difference between the highest and the lowest Total debt (in current US$) of Canada?
Make the answer very short. 4.20e+1. What is the difference between the highest and the lowest Total debt (in current US$) of France?
Your answer should be very brief. 3.50e+11. What is the difference between the highest and the lowest Total debt (in current US$) in Guatemala?
Ensure brevity in your answer.  2.53e+1. 